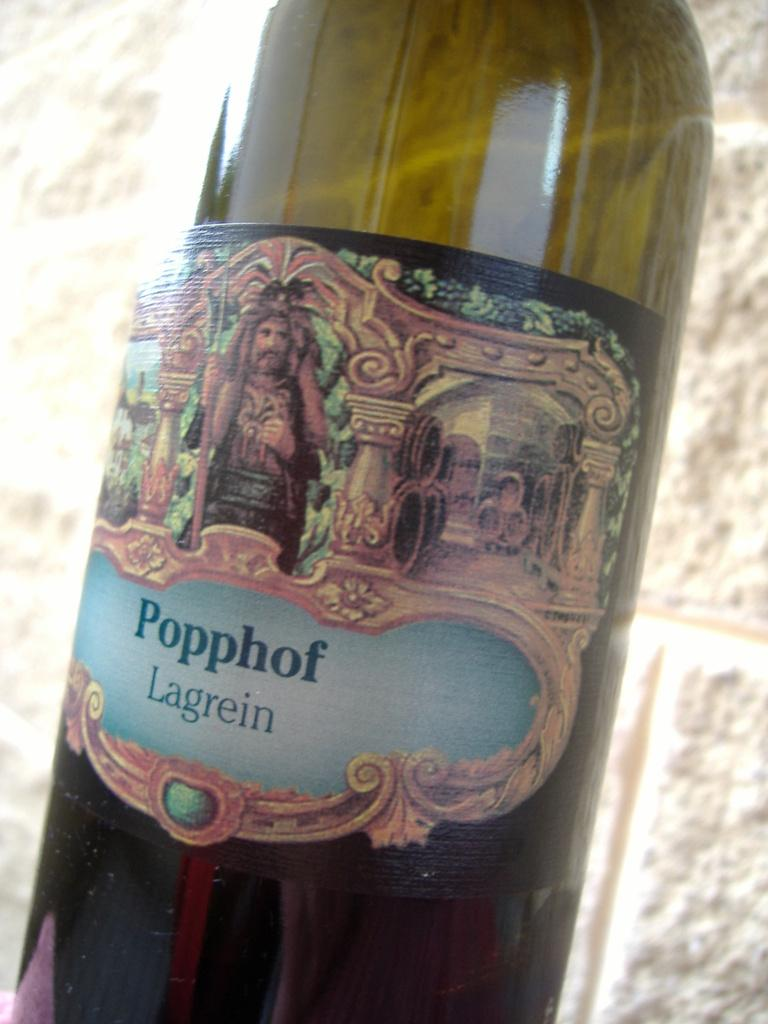<image>
Relay a brief, clear account of the picture shown. A bottle that has a light color of liquor that says Popphof Lagrein on the label. 